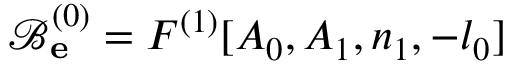Convert formula to latex. <formula><loc_0><loc_0><loc_500><loc_500>\mathcal { B } _ { e } ^ { ( 0 ) } = F ^ { ( 1 ) } [ A _ { 0 } , A _ { 1 } , n _ { 1 } , - l _ { 0 } ]</formula> 